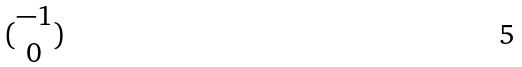<formula> <loc_0><loc_0><loc_500><loc_500>( \begin{matrix} - 1 \\ 0 \end{matrix} )</formula> 